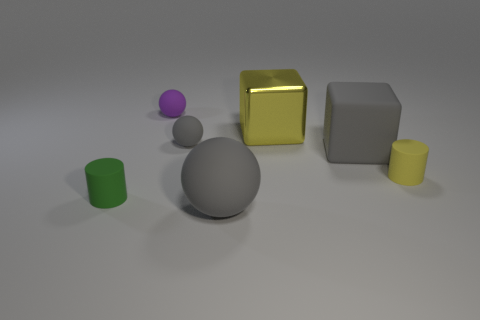Is the shape of the purple thing the same as the tiny gray matte object? The purple object and the tiny gray matte object are both spheres. However, they differ in terms of size and color, with the purple sphere being smaller and having a different hue compared to the larger gray sphere. 